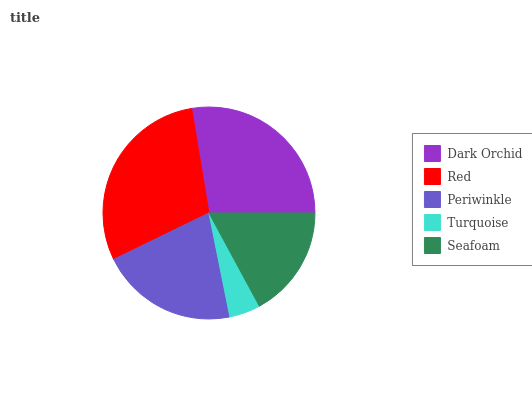Is Turquoise the minimum?
Answer yes or no. Yes. Is Red the maximum?
Answer yes or no. Yes. Is Periwinkle the minimum?
Answer yes or no. No. Is Periwinkle the maximum?
Answer yes or no. No. Is Red greater than Periwinkle?
Answer yes or no. Yes. Is Periwinkle less than Red?
Answer yes or no. Yes. Is Periwinkle greater than Red?
Answer yes or no. No. Is Red less than Periwinkle?
Answer yes or no. No. Is Periwinkle the high median?
Answer yes or no. Yes. Is Periwinkle the low median?
Answer yes or no. Yes. Is Turquoise the high median?
Answer yes or no. No. Is Turquoise the low median?
Answer yes or no. No. 